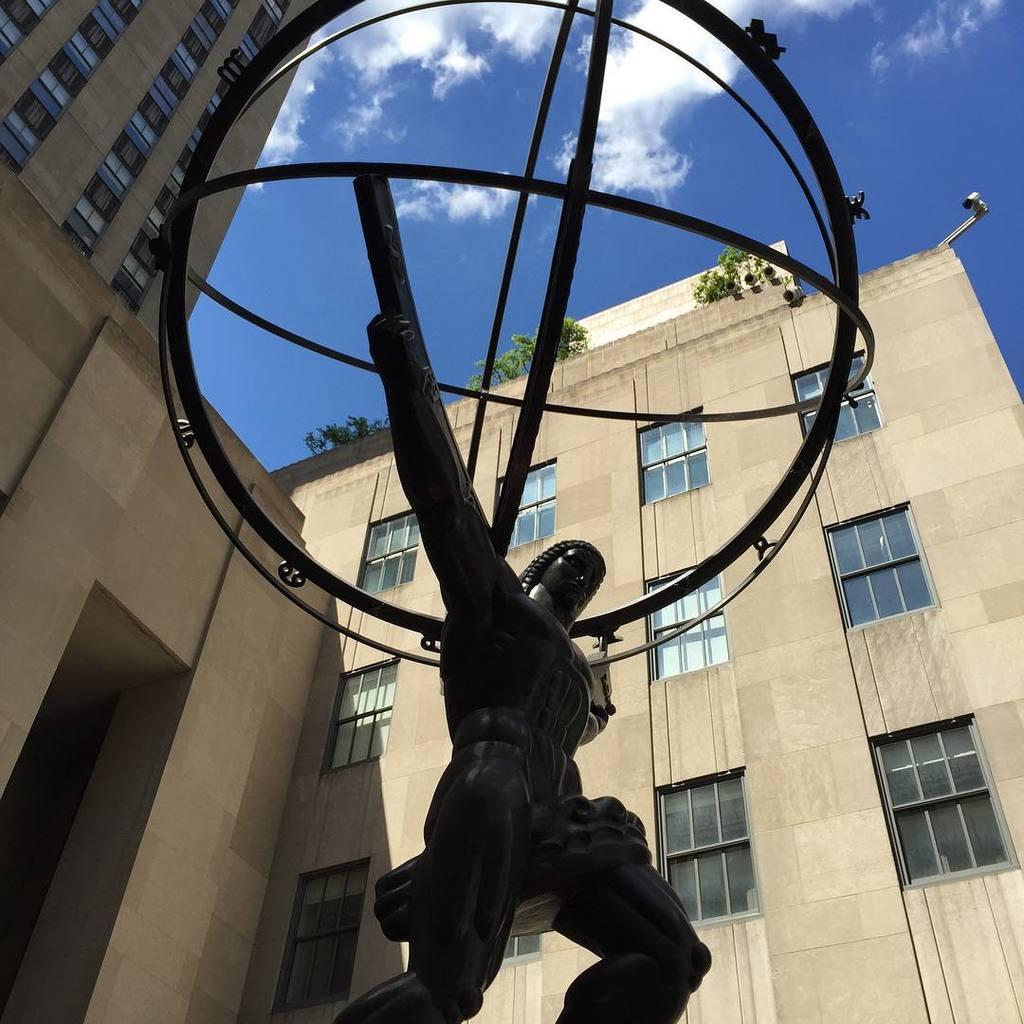In one or two sentences, can you explain what this image depicts? In this image we can see a sculpture. Behind buildings are there. The sky is in blue color with some clouds. 